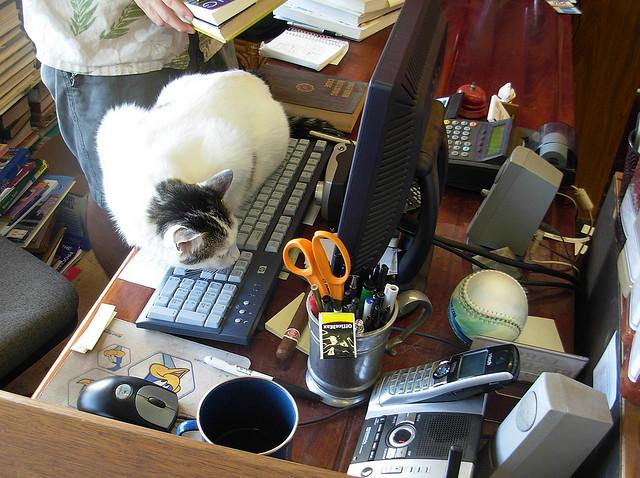What type tobacco product will the person who sits here smoke?

Choices:
A) snuff
B) cigar
C) hookah pipe
D) bong cigar 